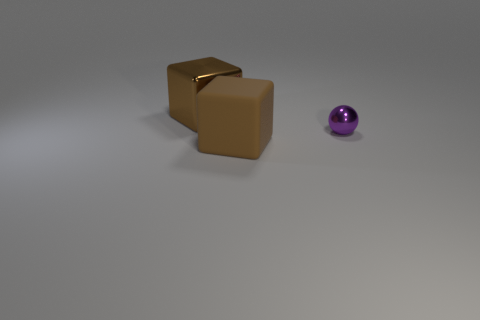What number of blocks are either small purple metal objects or rubber things?
Keep it short and to the point. 1. There is a big cube that is made of the same material as the tiny sphere; what color is it?
Ensure brevity in your answer.  Brown. Are there fewer metallic objects than green balls?
Provide a short and direct response. No. There is a brown object behind the big matte cube; is its shape the same as the big thing that is in front of the large shiny block?
Offer a very short reply. Yes. What number of things are small red spheres or matte blocks?
Provide a short and direct response. 1. There is a block that is the same size as the brown matte thing; what is its color?
Ensure brevity in your answer.  Brown. There is a brown block that is to the left of the large brown matte object; what number of big matte things are to the right of it?
Give a very brief answer. 1. What number of big cubes are behind the tiny purple metallic ball and in front of the large metal object?
Your answer should be very brief. 0. How many objects are brown metal blocks behind the purple shiny thing or large brown blocks that are in front of the tiny purple metal sphere?
Provide a short and direct response. 2. How many other things are the same size as the brown rubber object?
Make the answer very short. 1. 